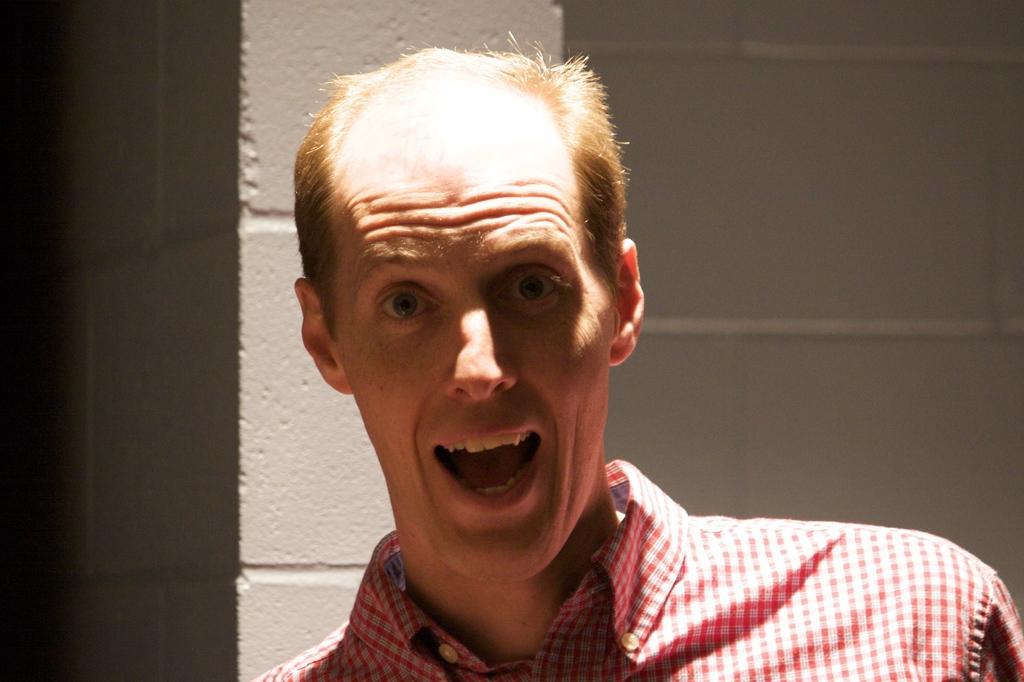Please provide a concise description of this image. In the center of the image there is a person. In the background of the image there is a wall. 